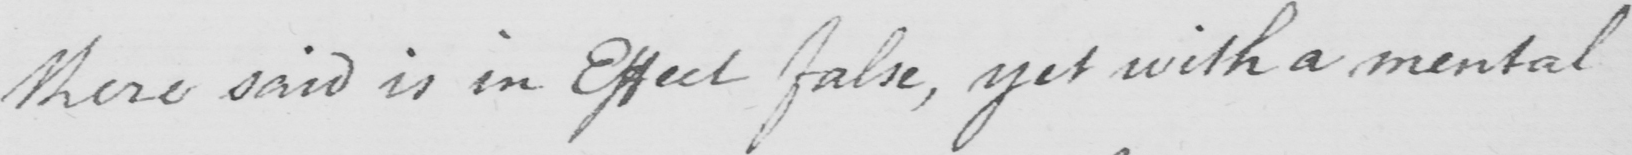What is written in this line of handwriting? there said is in Effect false , yet with a mental 